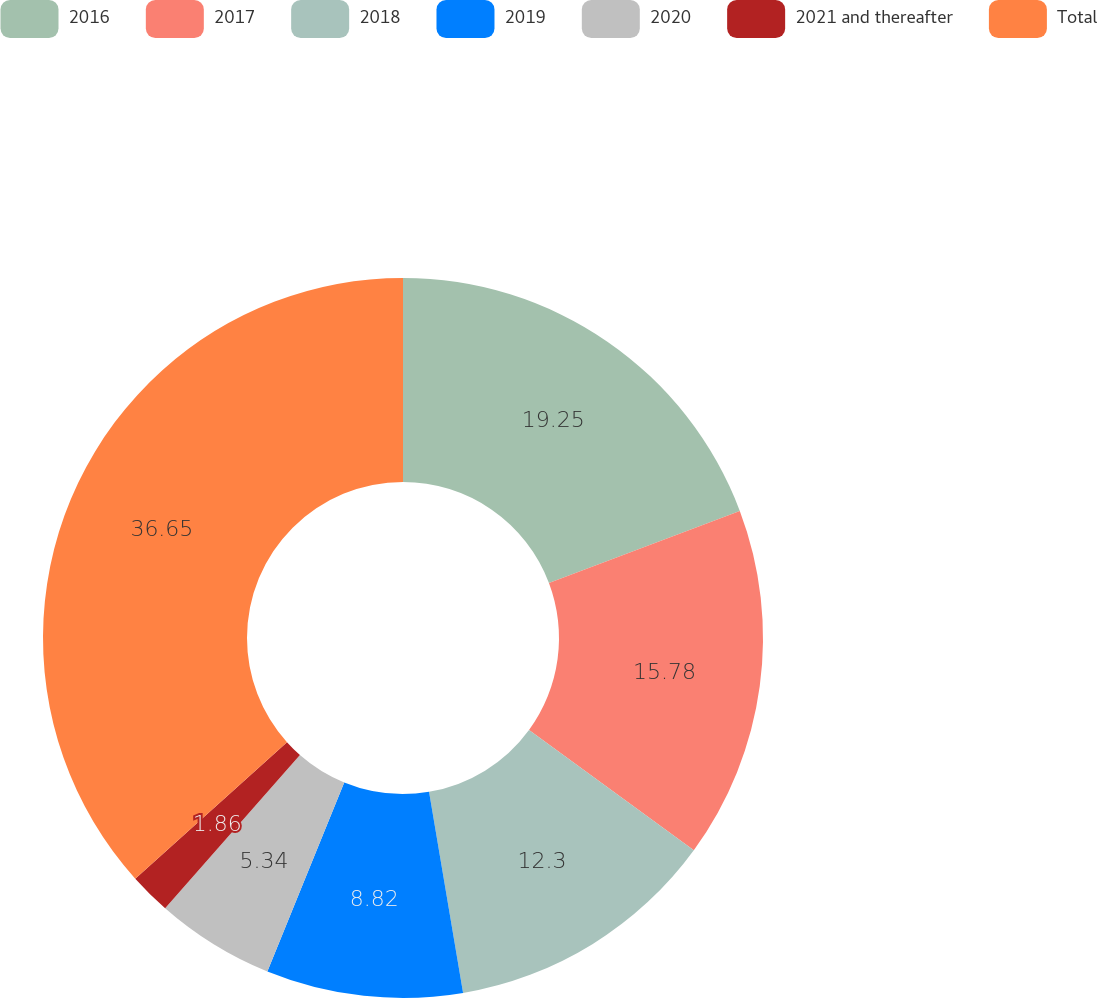Convert chart to OTSL. <chart><loc_0><loc_0><loc_500><loc_500><pie_chart><fcel>2016<fcel>2017<fcel>2018<fcel>2019<fcel>2020<fcel>2021 and thereafter<fcel>Total<nl><fcel>19.26%<fcel>15.78%<fcel>12.3%<fcel>8.82%<fcel>5.34%<fcel>1.86%<fcel>36.66%<nl></chart> 